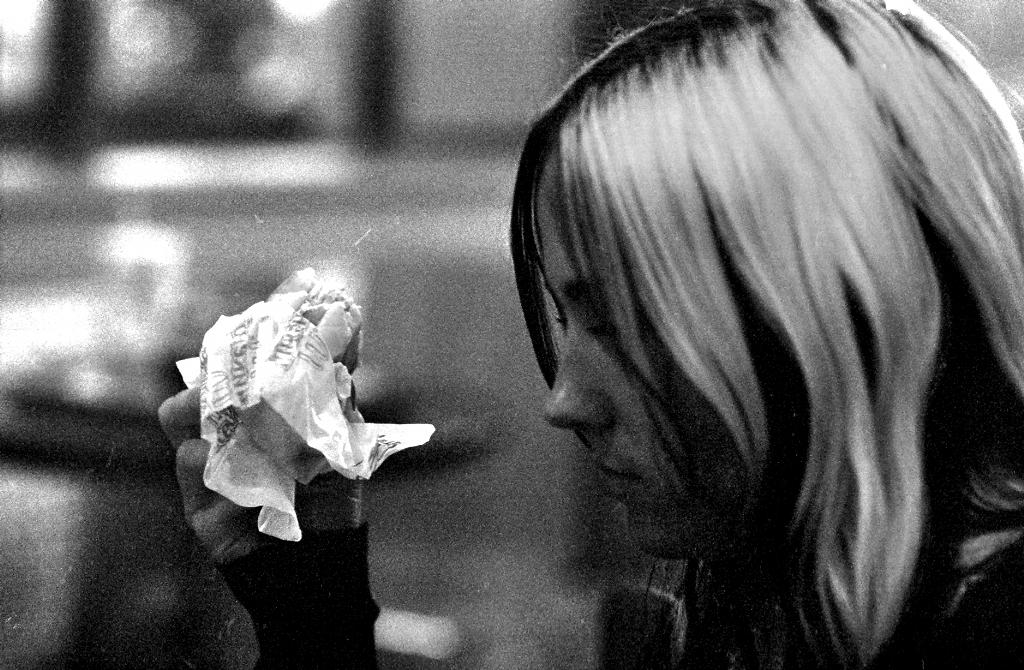What is the main subject of the image? There is a woman in the image. What is the woman holding in her hand? The woman is holding an object in her hand. Can you describe the background of the image? The background of the image is blurred. What is the color scheme of the image? The image is black and white in color. What type of stew is being prepared in the image? There is no stew present in the image; it features a woman holding an object in a black and white, blurred background. Can you point out the location of the map in the image? There is no map present in the image. 